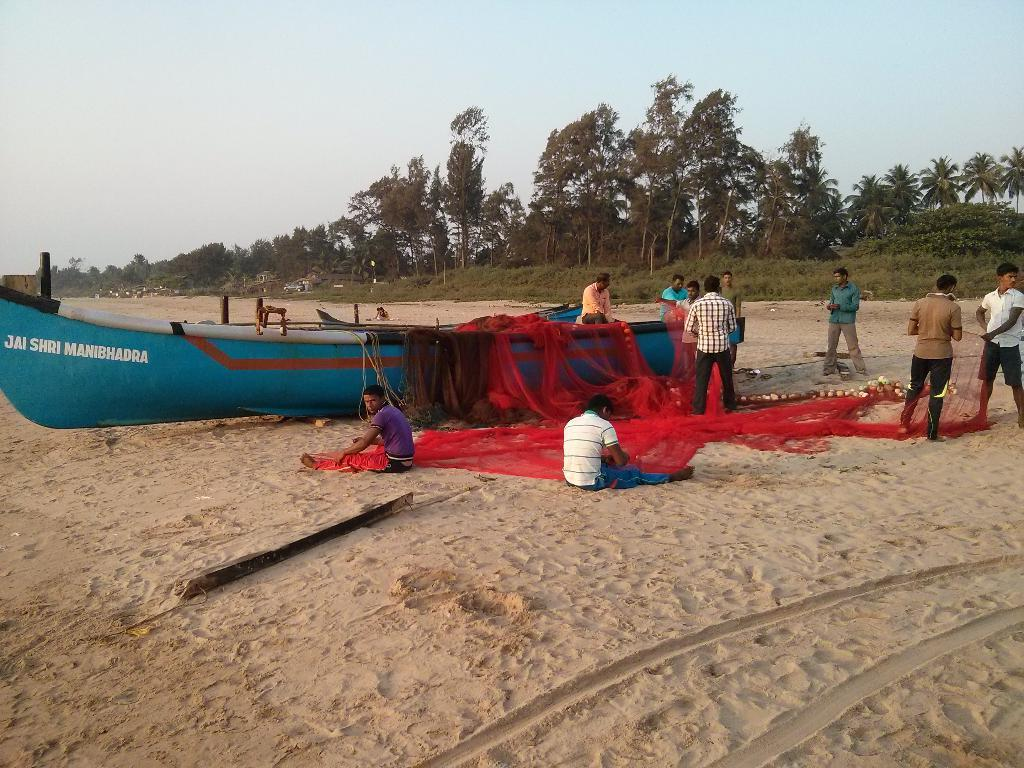What type of vehicles are present in the image? There are boats in the image. What objects are associated with the boats in the image? There are nets in the image. What can be seen in the middle of the image? There are persons in the middle of the image. What type of vegetation is visible in the background of the image? There are trees in the background of the image. What is visible at the top of the image? The sky is visible at the top of the image. Where is the oven located in the image? There is no oven present in the image. How many feet are visible in the image? There is no reference to feet in the image, so it is not possible to determine how many are visible. 